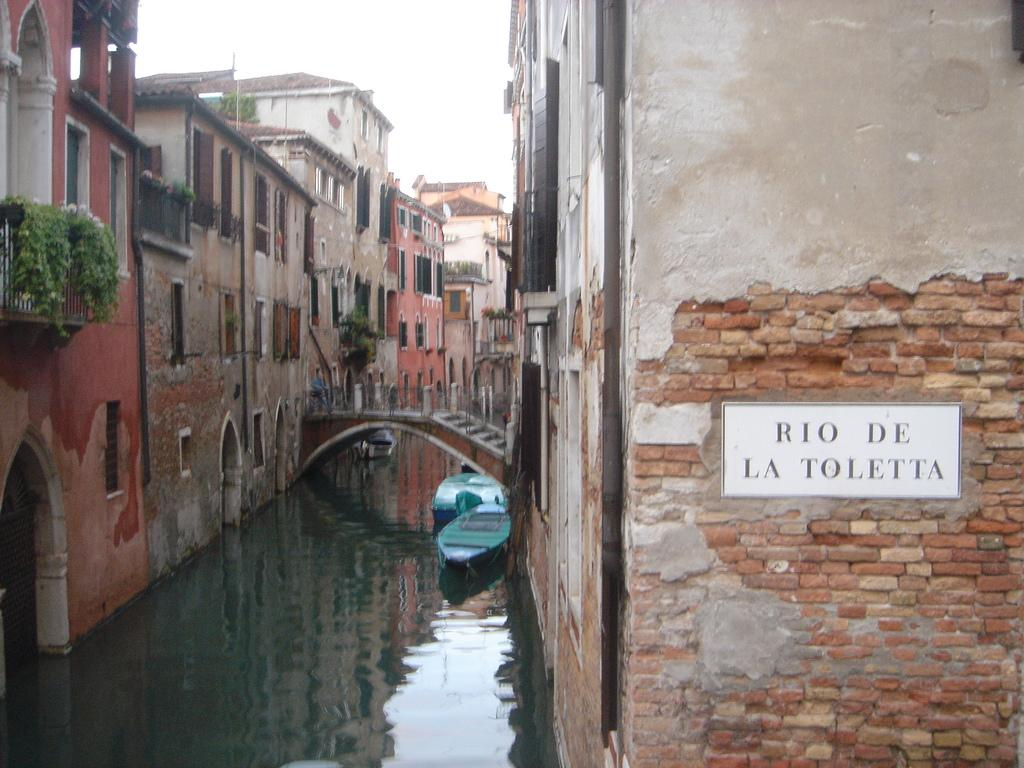What is attached to the brick wall in the image? There is a board attached to a brick wall in the image. What can be seen floating on the water in the image? Boats are floating on the water in the image. What structure is present in the image that connects two areas? There is a bridge in the image. What type of buildings can be seen in the image? Houses are visible in the image. What is visible in the background of the image? The sky is visible in the background of the image. What type of rhythm can be heard coming from the volcano in the image? There is no volcano present in the image, so it is not possible to determine any rhythm associated with it. 